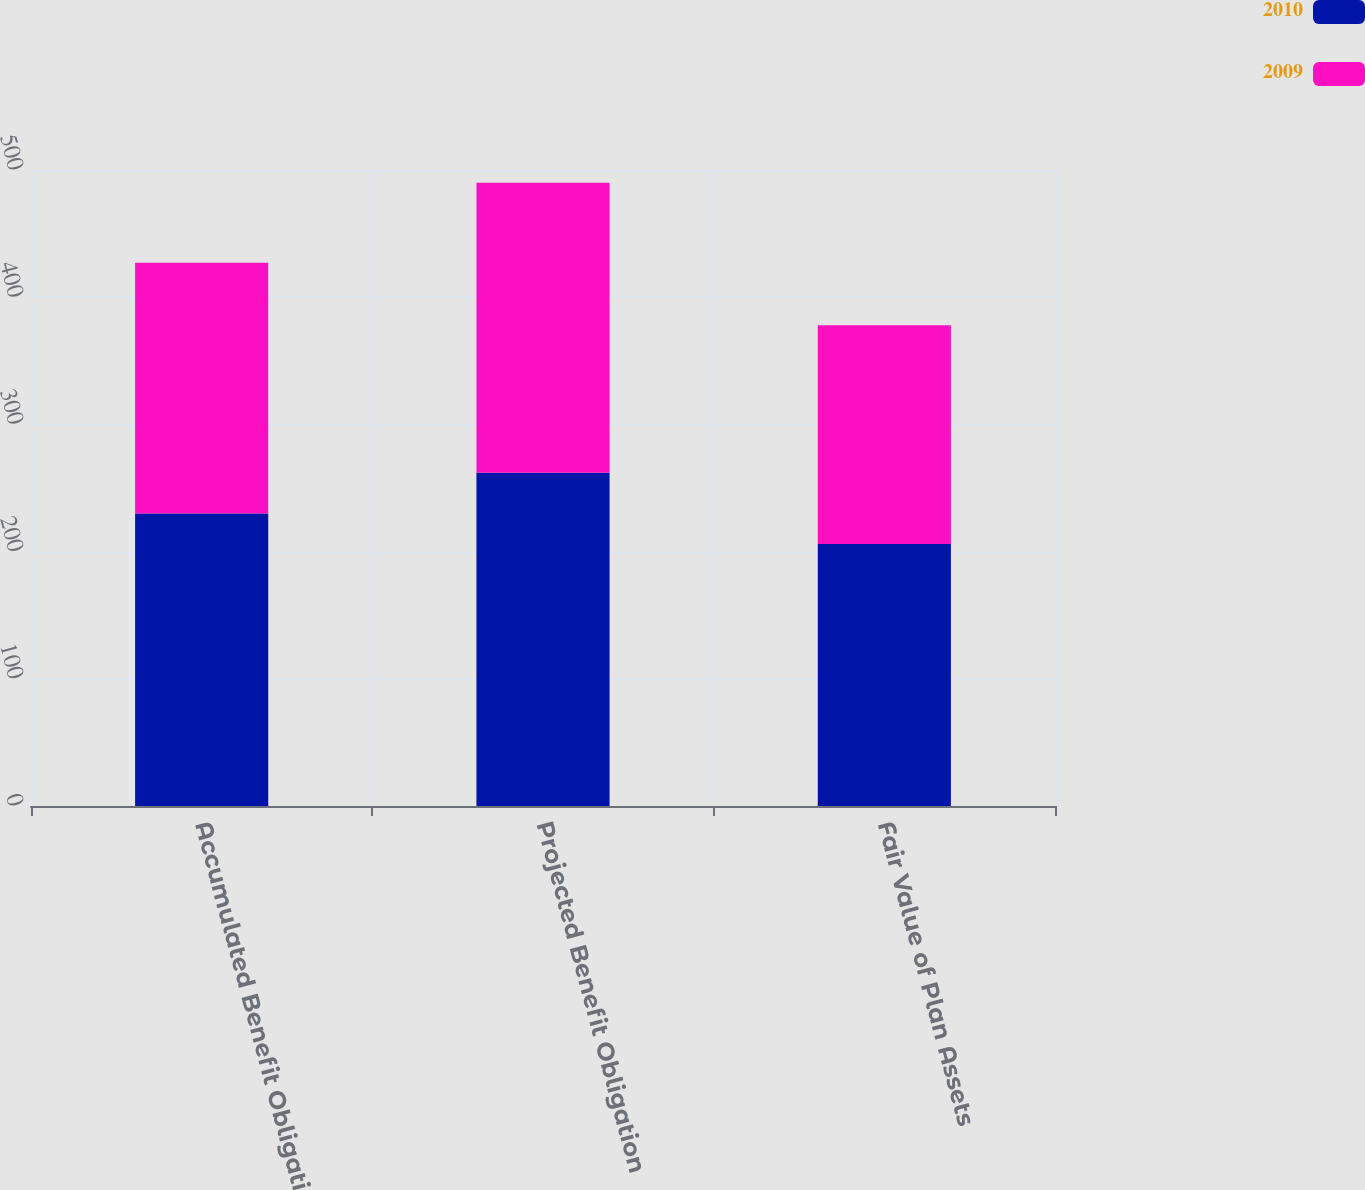Convert chart to OTSL. <chart><loc_0><loc_0><loc_500><loc_500><stacked_bar_chart><ecel><fcel>Accumulated Benefit Obligation<fcel>Projected Benefit Obligation<fcel>Fair Value of Plan Assets<nl><fcel>2010<fcel>230<fcel>262<fcel>206<nl><fcel>2009<fcel>197<fcel>228<fcel>172<nl></chart> 